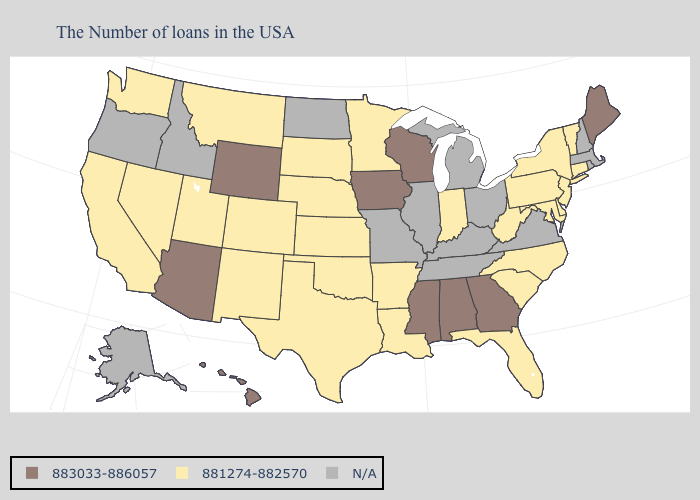Name the states that have a value in the range N/A?
Quick response, please. Massachusetts, Rhode Island, New Hampshire, Virginia, Ohio, Michigan, Kentucky, Tennessee, Illinois, Missouri, North Dakota, Idaho, Oregon, Alaska. What is the lowest value in the USA?
Short answer required. 881274-882570. What is the highest value in the West ?
Write a very short answer. 883033-886057. Name the states that have a value in the range N/A?
Be succinct. Massachusetts, Rhode Island, New Hampshire, Virginia, Ohio, Michigan, Kentucky, Tennessee, Illinois, Missouri, North Dakota, Idaho, Oregon, Alaska. Name the states that have a value in the range N/A?
Be succinct. Massachusetts, Rhode Island, New Hampshire, Virginia, Ohio, Michigan, Kentucky, Tennessee, Illinois, Missouri, North Dakota, Idaho, Oregon, Alaska. Name the states that have a value in the range 883033-886057?
Short answer required. Maine, Georgia, Alabama, Wisconsin, Mississippi, Iowa, Wyoming, Arizona, Hawaii. Name the states that have a value in the range 881274-882570?
Write a very short answer. Vermont, Connecticut, New York, New Jersey, Delaware, Maryland, Pennsylvania, North Carolina, South Carolina, West Virginia, Florida, Indiana, Louisiana, Arkansas, Minnesota, Kansas, Nebraska, Oklahoma, Texas, South Dakota, Colorado, New Mexico, Utah, Montana, Nevada, California, Washington. Name the states that have a value in the range 883033-886057?
Be succinct. Maine, Georgia, Alabama, Wisconsin, Mississippi, Iowa, Wyoming, Arizona, Hawaii. What is the value of Colorado?
Quick response, please. 881274-882570. Name the states that have a value in the range 883033-886057?
Write a very short answer. Maine, Georgia, Alabama, Wisconsin, Mississippi, Iowa, Wyoming, Arizona, Hawaii. What is the highest value in states that border Nebraska?
Short answer required. 883033-886057. Which states have the lowest value in the USA?
Concise answer only. Vermont, Connecticut, New York, New Jersey, Delaware, Maryland, Pennsylvania, North Carolina, South Carolina, West Virginia, Florida, Indiana, Louisiana, Arkansas, Minnesota, Kansas, Nebraska, Oklahoma, Texas, South Dakota, Colorado, New Mexico, Utah, Montana, Nevada, California, Washington. Is the legend a continuous bar?
Short answer required. No. 